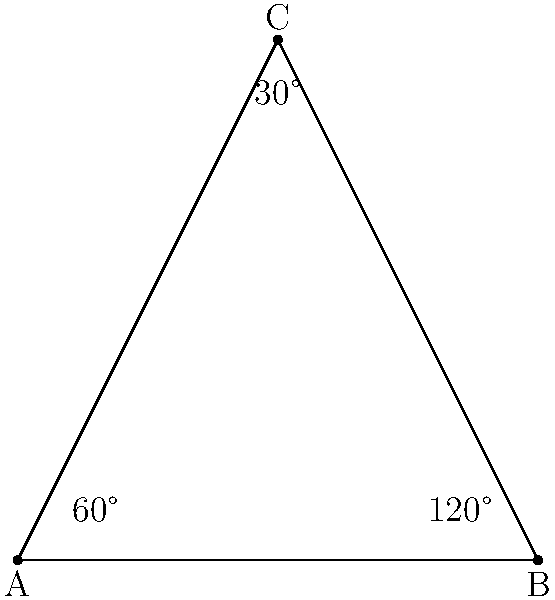In this stylized company logo, which consists of a triangle with some angle measurements, can you identify a pair of complementary angles? To answer this question, let's follow these steps:

1. Recall the definitions:
   - Complementary angles: Two angles that add up to 90°
   - Supplementary angles: Two angles that add up to 180°

2. Observe the given angles in the logo:
   - We can see angles of 60°, 120°, and 30°

3. Check for complementary pairs:
   - 60° + 30° = 90°
   - 120° + 30° ≠ 90°
   - 120° + 60° ≠ 90°

4. Identify the complementary pair:
   The 60° angle and the 30° angle form a complementary pair because they add up to 90°.

Note: While not asked in the question, we can also observe that the 60° and 120° angles are supplementary, as they add up to 180°.
Answer: 60° and 30° 